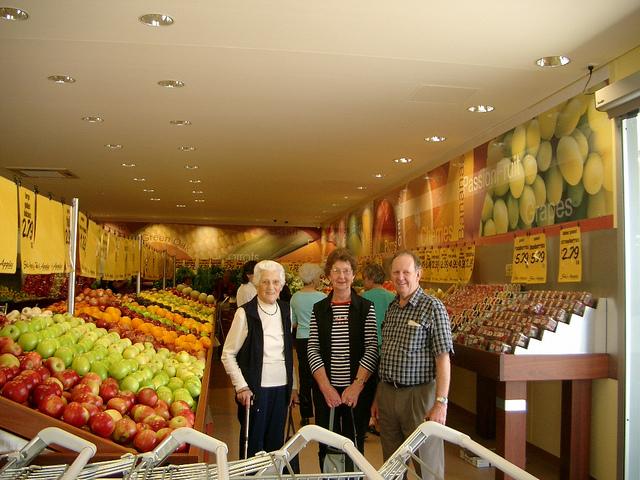Are the people young?
Answer briefly. No. Do these people like shopping for produce?
Short answer required. Yes. What type of shirt is the man wearing?
Keep it brief. Plaid. 